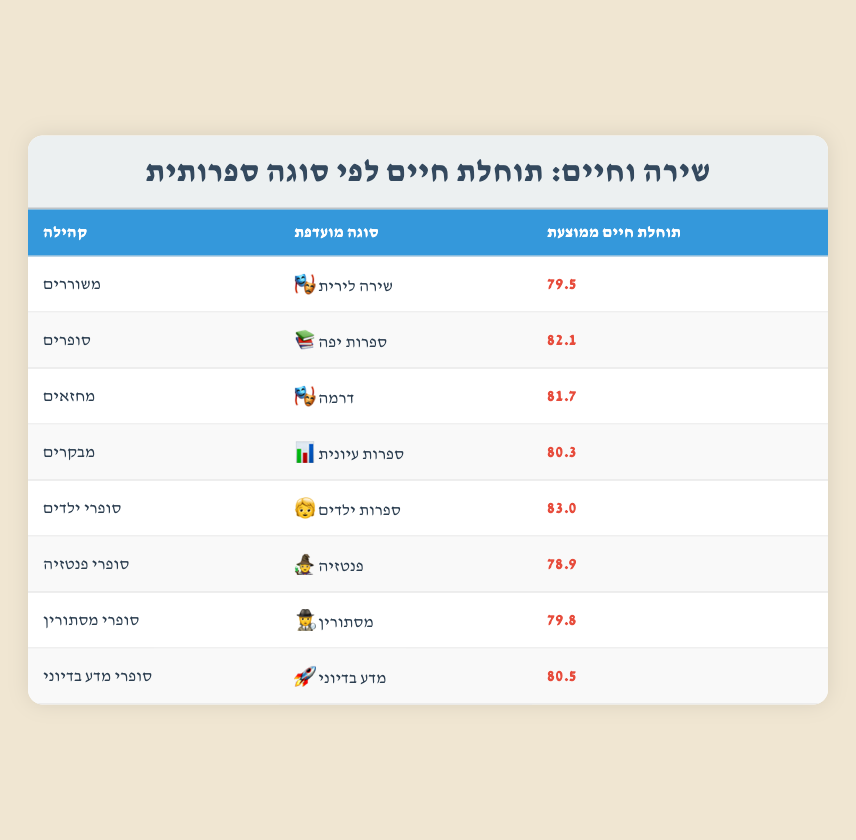What is the average life expectancy of poets? The table lists the average life expectancy for poets as 79.5 years in the row corresponding to the "Poets" community.
Answer: 79.5 Which literary genre preference has the highest average life expectancy? The highest average life expectancy is listed for "Children's Authors" at 83.0 years, which can be found in the corresponding row for that community.
Answer: 83.0 How much longer do novelists live compared to fantasy writers? Novelists have an average life expectancy of 82.1 years while fantasy writers have an average of 78.9 years. The difference is 82.1 - 78.9 = 3.2 years.
Answer: 3.2 Is it true that mystery authors have a higher average life expectancy than poets? The average life expectancy for mystery authors is 79.8 years, while for poets it is 79.5 years. Therefore, mystery authors live longer than poets by 0.3 years, which confirms the statement.
Answer: Yes What is the overall average life expectancy of the communities listed in the table? To find the overall average, we sum the life expectancies: (79.5 + 82.1 + 81.7 + 80.3 + 83.0 + 78.9 + 79.8 + 80.5) = 646.8. There are 8 communities, so the average is 646.8 / 8 = 80.85 years.
Answer: 80.85 Which community has a preferred genre of drama, and what is their average life expectancy? The community that prefers drama is "Playwrights," which is shown in the corresponding row with an average life expectancy of 81.7 years.
Answer: Playwrights, 81.7 Do critics have a higher life expectancy than children's authors? Critics have an average life expectancy of 80.3 years, while children's authors have an average of 83.0 years. Since 80.3 is less than 83.0, the statement is false.
Answer: No How do the life expectancy averages compare between playwrights and science fiction writers? Playwrights have an average life expectancy of 81.7 years, while science fiction writers have an average of 80.5 years. Comparing the two shows that playwrights live longer by 1.2 years (81.7 - 80.5).
Answer: 1.2 